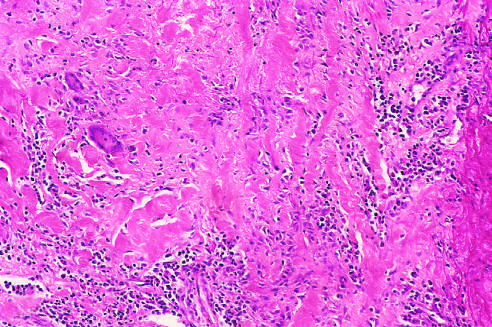how is histologic appearance in active takayasu aortitis illustrating destruction and fibrosis of the arterial media associated?
Answer the question using a single word or phrase. With mononuclear infiltrates 